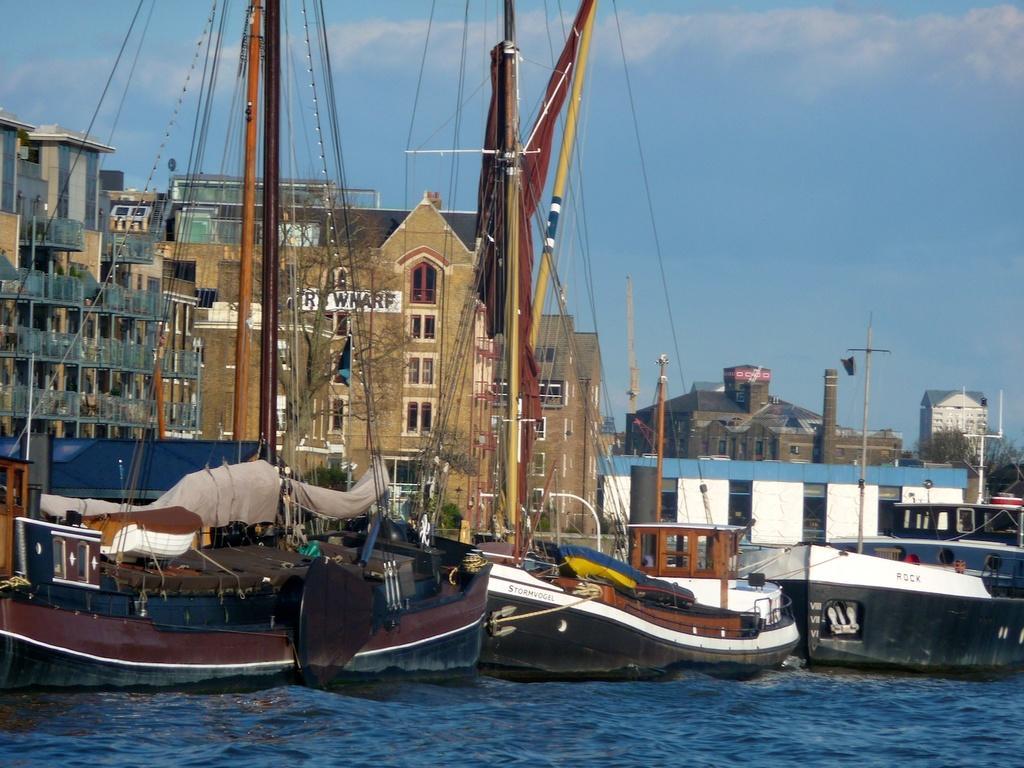How would you summarize this image in a sentence or two? In this image I can see the water and few boats which are white, brown and black in color on the surface of the water. In the background I can see few buildings, few trees and the sky. 